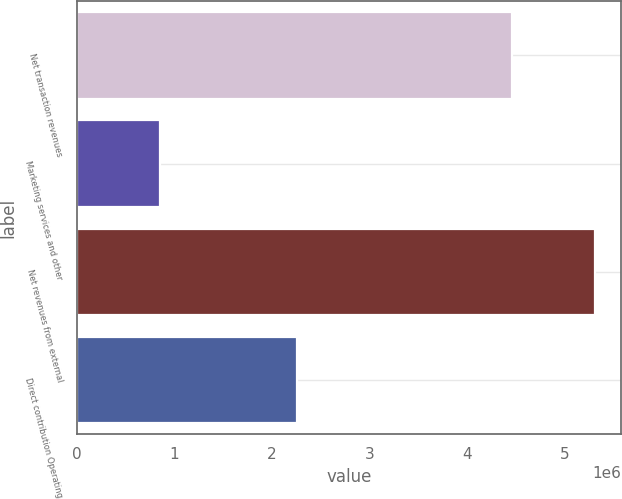Convert chart. <chart><loc_0><loc_0><loc_500><loc_500><bar_chart><fcel>Net transaction revenues<fcel>Marketing services and other<fcel>Net revenues from external<fcel>Direct contribution Operating<nl><fcel>4.46184e+06<fcel>849169<fcel>5.31101e+06<fcel>2.25192e+06<nl></chart> 